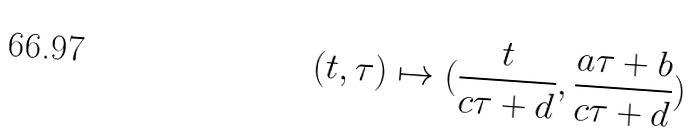<formula> <loc_0><loc_0><loc_500><loc_500>( t , \tau ) \mapsto ( \frac { t } { c \tau + d } , \frac { a \tau + b } { c \tau + d } )</formula> 